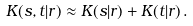Convert formula to latex. <formula><loc_0><loc_0><loc_500><loc_500>K ( s , t | r ) \approx K ( s | r ) + K ( t | r ) \, .</formula> 